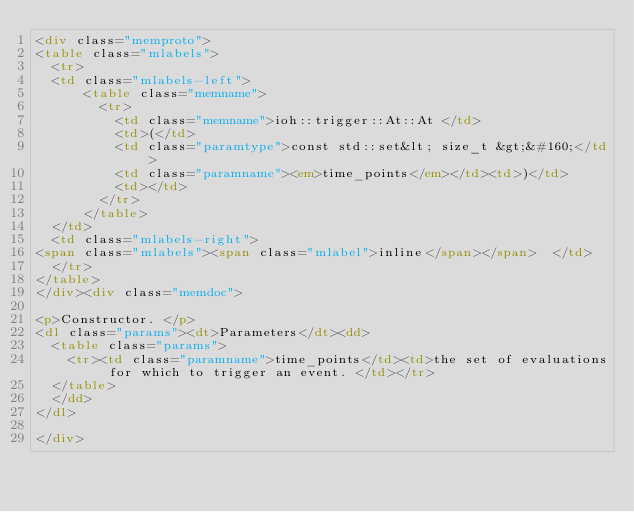Convert code to text. <code><loc_0><loc_0><loc_500><loc_500><_HTML_><div class="memproto">
<table class="mlabels">
  <tr>
  <td class="mlabels-left">
      <table class="memname">
        <tr>
          <td class="memname">ioh::trigger::At::At </td>
          <td>(</td>
          <td class="paramtype">const std::set&lt; size_t &gt;&#160;</td>
          <td class="paramname"><em>time_points</em></td><td>)</td>
          <td></td>
        </tr>
      </table>
  </td>
  <td class="mlabels-right">
<span class="mlabels"><span class="mlabel">inline</span></span>  </td>
  </tr>
</table>
</div><div class="memdoc">

<p>Constructor. </p>
<dl class="params"><dt>Parameters</dt><dd>
  <table class="params">
    <tr><td class="paramname">time_points</td><td>the set of evaluations for which to trigger an event. </td></tr>
  </table>
  </dd>
</dl>

</div></code> 